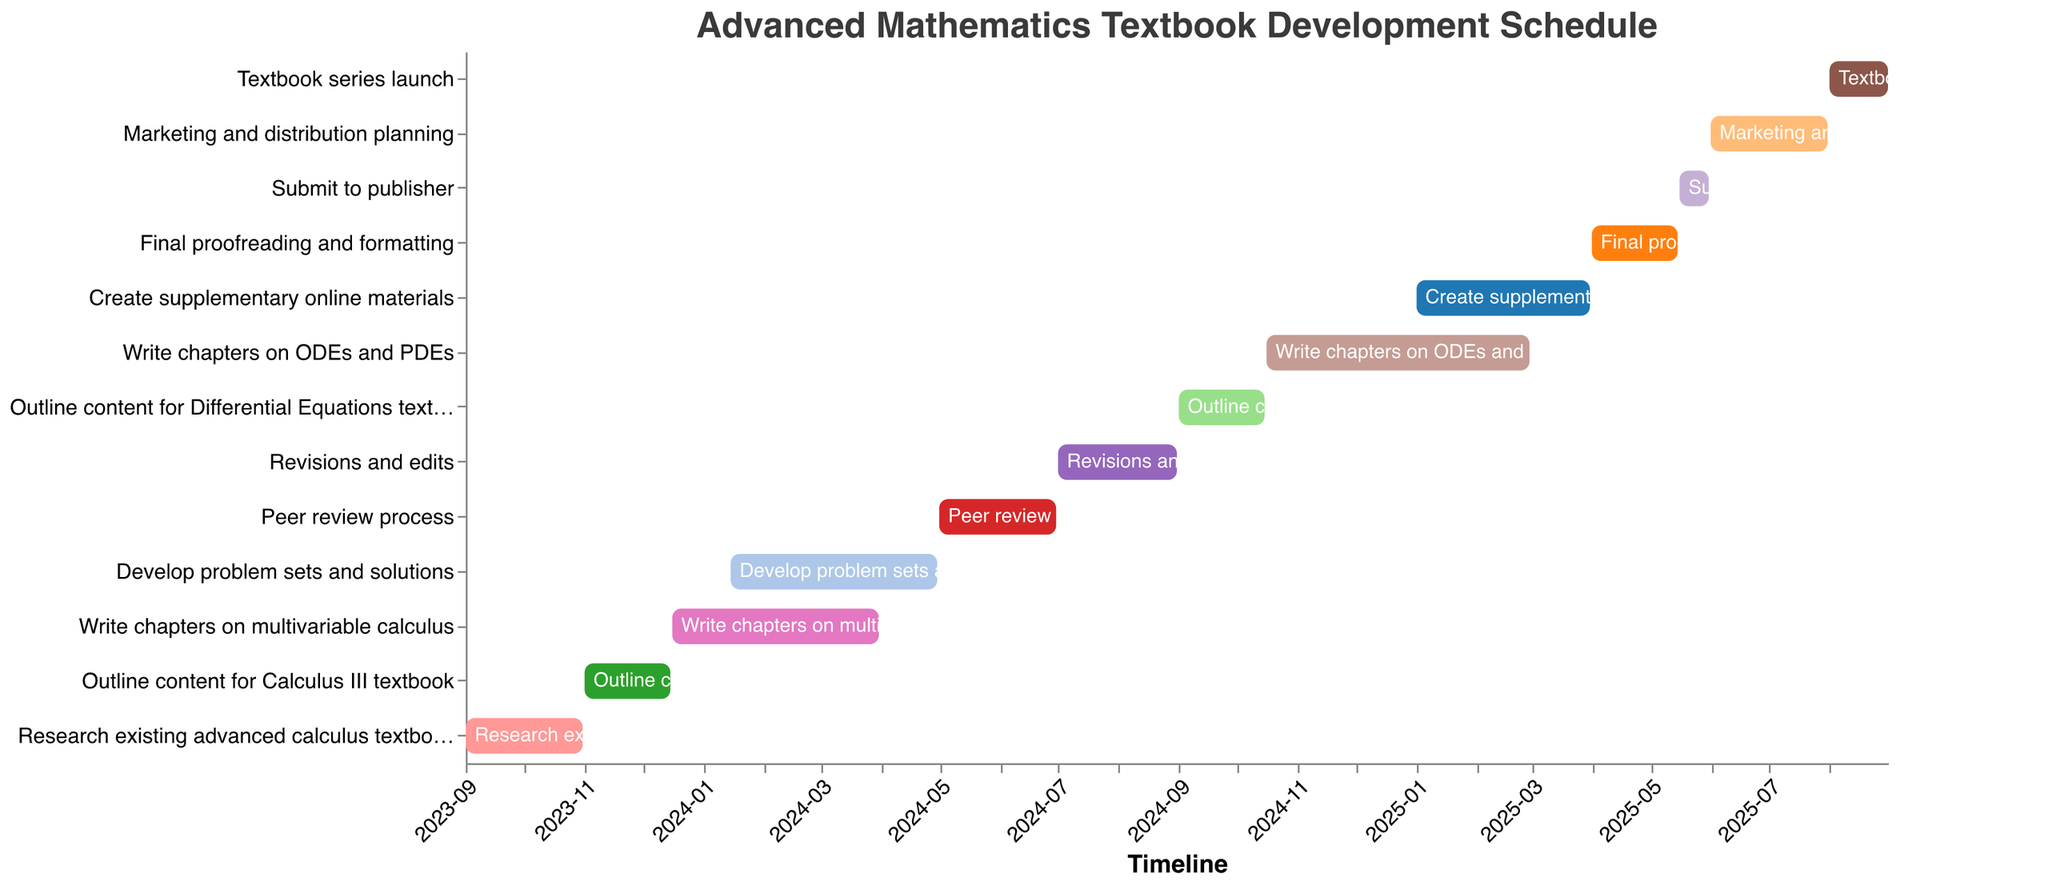What is the title of the figure? The title is at the top of the figure and is typically larger and bolder than other text.
Answer: Advanced Mathematics Textbook Development Schedule Which task has the earliest starting date? Check the "Task" with the earliest "Start" date on the x-axis timeline.
Answer: Research existing advanced calculus textbooks When does the task "Write chapters on ODEs and PDEs" end? Look for the bar labeled "Write chapters on ODEs and PDEs" and find its ending date on the x-axis.
Answer: 2025-02-28 How long is the peer review process? Calculate the duration from the start date to the end date of the "Peer review process". This involves counting the months between 2024-05-01 and 2024-06-30.
Answer: 2 months Which task overlaps with the "Write chapters on multivariable calculus" task? Identify which tasks share any timeline with "Write chapters on multivariable calculus" by comparing their dates.
Answer: Develop problem sets and solutions What task immediately follows "Revisions and edits"? Look for the next task that starts after "Revisions and edits" ends on the timeline.
Answer: Outline content for Differential Equations textbook Which task spans the longest duration? Compare the length of each task's bar on the timeline, where the longest bar represents the longest duration.
Answer: Write chapters on multivariable calculus How many tasks are scheduled between January 2025 and June 2025? Count the number of tasks that start, end, or span through the period from January 2025 to June 2025.
Answer: 4 tasks (Create supplementary online materials, Final proofreading and formatting, Submit to publisher, Marketing and distribution planning) Which tasks have their start date in 2024? Identify the tasks whose "Start" date falls within the year 2024.
Answer: Develop problem sets and solutions, Peer review process, Revisions and edits, Outline content for Differential Equations textbook, Write chapters on ODEs and PDEs During which months does the "Textbook series launch" occur? Look at the start and end dates of "Textbook series launch" and identify the months it spans.
Answer: August 2025 